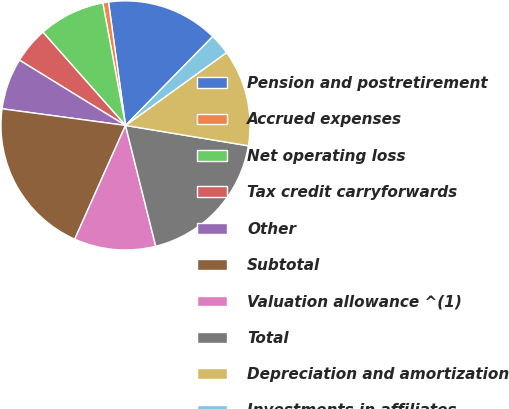Convert chart. <chart><loc_0><loc_0><loc_500><loc_500><pie_chart><fcel>Pension and postretirement<fcel>Accrued expenses<fcel>Net operating loss<fcel>Tax credit carryforwards<fcel>Other<fcel>Subtotal<fcel>Valuation allowance ^(1)<fcel>Total<fcel>Depreciation and amortization<fcel>Investments in affiliates<nl><fcel>14.53%<fcel>0.74%<fcel>8.62%<fcel>4.68%<fcel>6.65%<fcel>20.45%<fcel>10.59%<fcel>18.48%<fcel>12.56%<fcel>2.71%<nl></chart> 